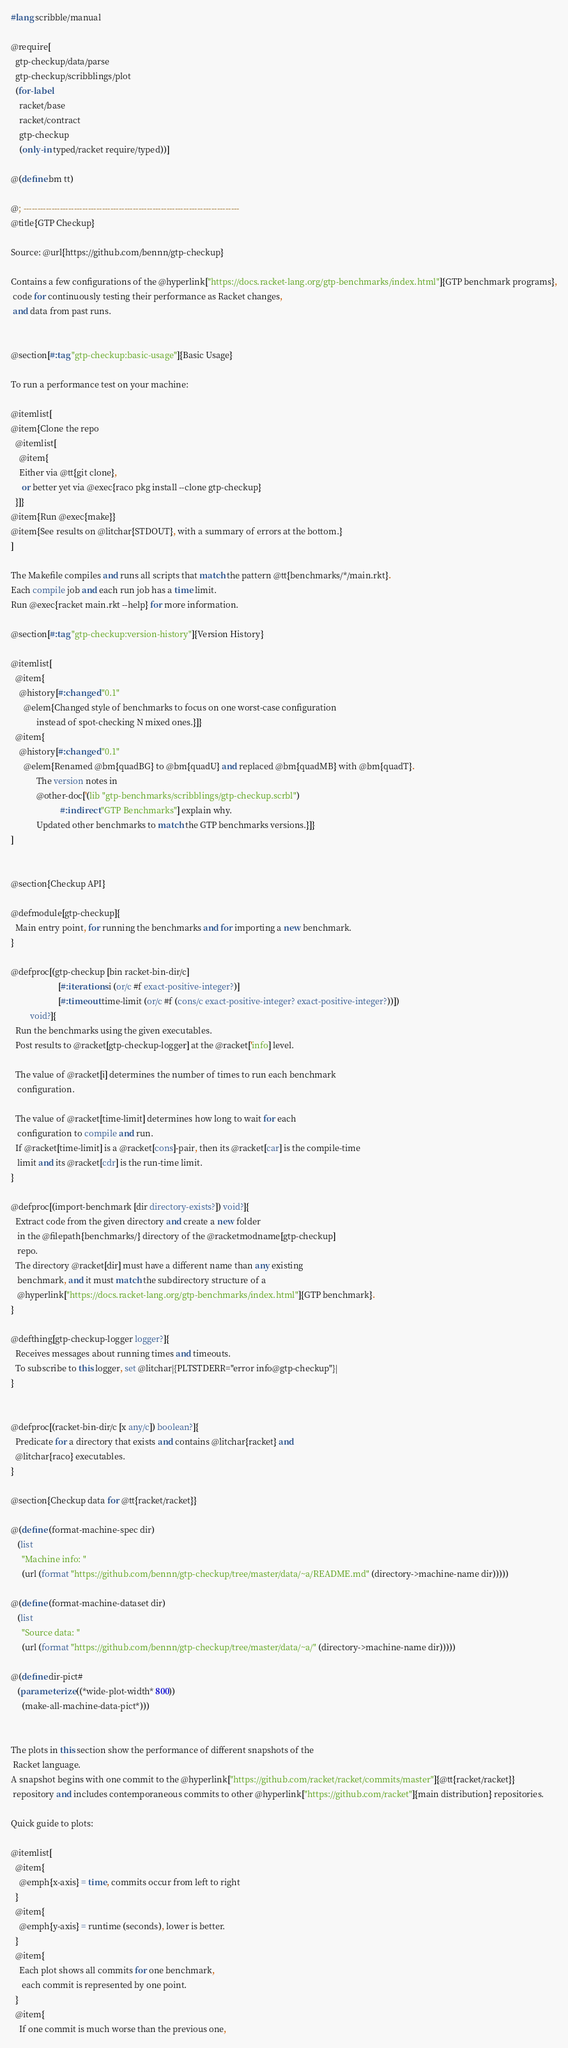Convert code to text. <code><loc_0><loc_0><loc_500><loc_500><_Racket_>#lang scribble/manual

@require[
  gtp-checkup/data/parse
  gtp-checkup/scribblings/plot
  (for-label
    racket/base
    racket/contract
    gtp-checkup
    (only-in typed/racket require/typed))]

@(define bm tt)

@; -----------------------------------------------------------------------------
@title{GTP Checkup}

Source: @url{https://github.com/bennn/gtp-checkup}

Contains a few configurations of the @hyperlink["https://docs.racket-lang.org/gtp-benchmarks/index.html"]{GTP benchmark programs},
 code for continuously testing their performance as Racket changes,
 and data from past runs.


@section[#:tag "gtp-checkup:basic-usage"]{Basic Usage}

To run a performance test on your machine:

@itemlist[
@item{Clone the repo
  @itemlist[
    @item{
    Either via @tt{git clone},
     or better yet via @exec{raco pkg install --clone gtp-checkup}
  }]}
@item{Run @exec{make}}
@item{See results on @litchar{STDOUT}, with a summary of errors at the bottom.}
]

The Makefile compiles and runs all scripts that match the pattern @tt{benchmarks/*/main.rkt}.
Each compile job and each run job has a time limit.
Run @exec{racket main.rkt --help} for more information.

@section[#:tag "gtp-checkup:version-history"]{Version History}

@itemlist[
  @item{
    @history[#:changed "0.1"
      @elem{Changed style of benchmarks to focus on one worst-case configuration
            instead of spot-checking N mixed ones.}]}
  @item{
    @history[#:changed "0.1"
      @elem{Renamed @bm{quadBG} to @bm{quadU} and replaced @bm{quadMB} with @bm{quadT}.
            The version notes in
            @other-doc['(lib "gtp-benchmarks/scribblings/gtp-checkup.scrbl")
                       #:indirect "GTP Benchmarks"] explain why.
            Updated other benchmarks to match the GTP benchmarks versions.}]}
]


@section{Checkup API}

@defmodule[gtp-checkup]{
  Main entry point, for running the benchmarks and for importing a new benchmark.
}

@defproc[(gtp-checkup [bin racket-bin-dir/c]
                      [#:iterations i (or/c #f exact-positive-integer?)]
                      [#:timeout time-limit (or/c #f (cons/c exact-positive-integer? exact-positive-integer?))])
         void?]{
  Run the benchmarks using the given executables.
  Post results to @racket[gtp-checkup-logger] at the @racket['info] level.

  The value of @racket[i] determines the number of times to run each benchmark
   configuration.

  The value of @racket[time-limit] determines how long to wait for each
   configuration to compile and run.
  If @racket[time-limit] is a @racket[cons]-pair, then its @racket[car] is the compile-time
   limit and its @racket[cdr] is the run-time limit.
}

@defproc[(import-benchmark [dir directory-exists?]) void?]{
  Extract code from the given directory and create a new folder
   in the @filepath{benchmarks/} directory of the @racketmodname[gtp-checkup]
   repo.
  The directory @racket[dir] must have a different name than any existing
   benchmark, and it must match the subdirectory structure of a
   @hyperlink["https://docs.racket-lang.org/gtp-benchmarks/index.html"]{GTP benchmark}.
}

@defthing[gtp-checkup-logger logger?]{
  Receives messages about running times and timeouts.
  To subscribe to this logger, set @litchar|{PLTSTDERR="error info@gtp-checkup"}|
}


@defproc[(racket-bin-dir/c [x any/c]) boolean?]{
  Predicate for a directory that exists and contains @litchar{racket} and
  @litchar{raco} executables.
}

@section{Checkup data for @tt{racket/racket}}

@(define (format-machine-spec dir)
   (list
     "Machine info: "
     (url (format "https://github.com/bennn/gtp-checkup/tree/master/data/~a/README.md" (directory->machine-name dir)))))

@(define (format-machine-dataset dir)
   (list
     "Source data: "
     (url (format "https://github.com/bennn/gtp-checkup/tree/master/data/~a/" (directory->machine-name dir)))))

@(define dir-pict#
   (parameterize ((*wide-plot-width* 800))
     (make-all-machine-data-pict*)))


The plots in this section show the performance of different snapshots of the
 Racket language.
A snapshot begins with one commit to the @hyperlink["https://github.com/racket/racket/commits/master"]{@tt{racket/racket}}
 repository and includes contemporaneous commits to other @hyperlink["https://github.com/racket"]{main distribution} repositories.

Quick guide to plots:

@itemlist[
  @item{
    @emph{x-axis} = time, commits occur from left to right
  }
  @item{
    @emph{y-axis} = runtime (seconds), lower is better.
  }
  @item{
    Each plot shows all commits for one benchmark,
     each commit is represented by one point.
  }
  @item{
    If one commit is much worse than the previous one,</code> 